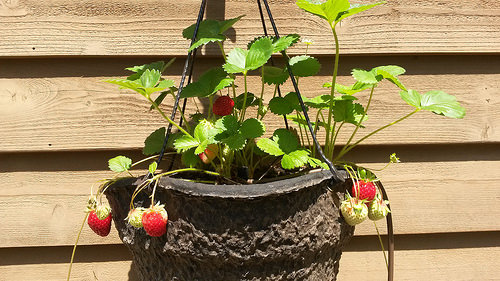<image>
Can you confirm if the strawberry is in the pot? No. The strawberry is not contained within the pot. These objects have a different spatial relationship. 